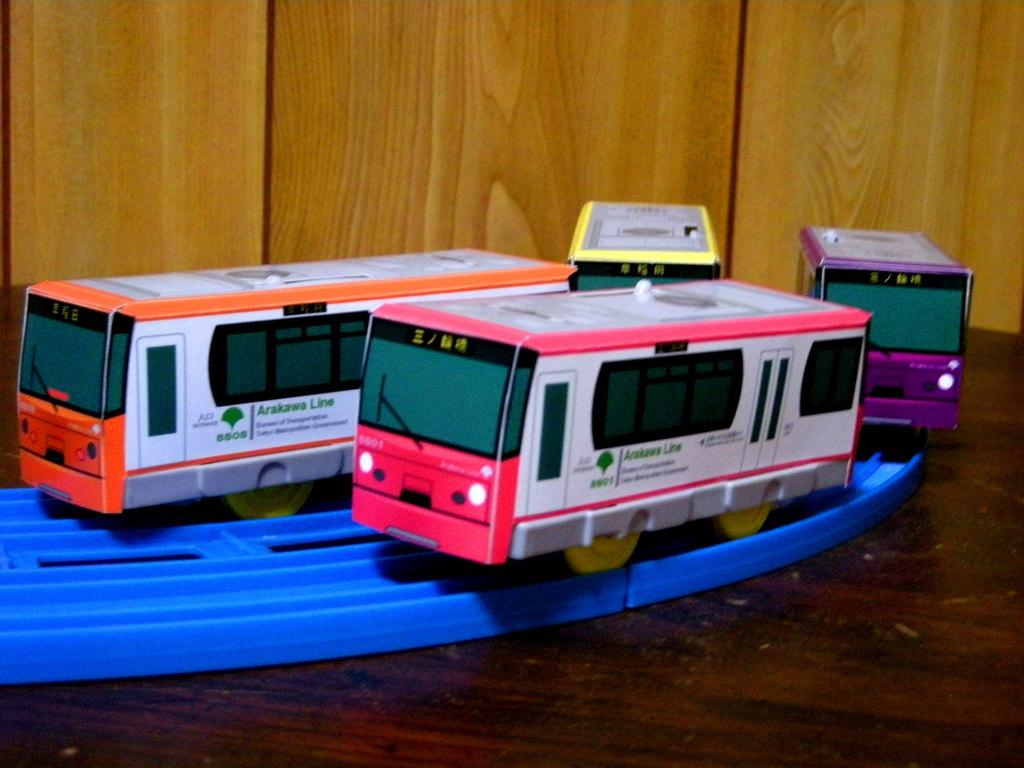What objects are on the wooden surface in the image? There are toys on a wooden surface in the image. What type of material is the wall in the background of the image? There is a wooden wall in the background of the image. How does the image represent the concept of moving? The image does not represent the concept of moving, as the toys and wooden wall are stationary in the image. 